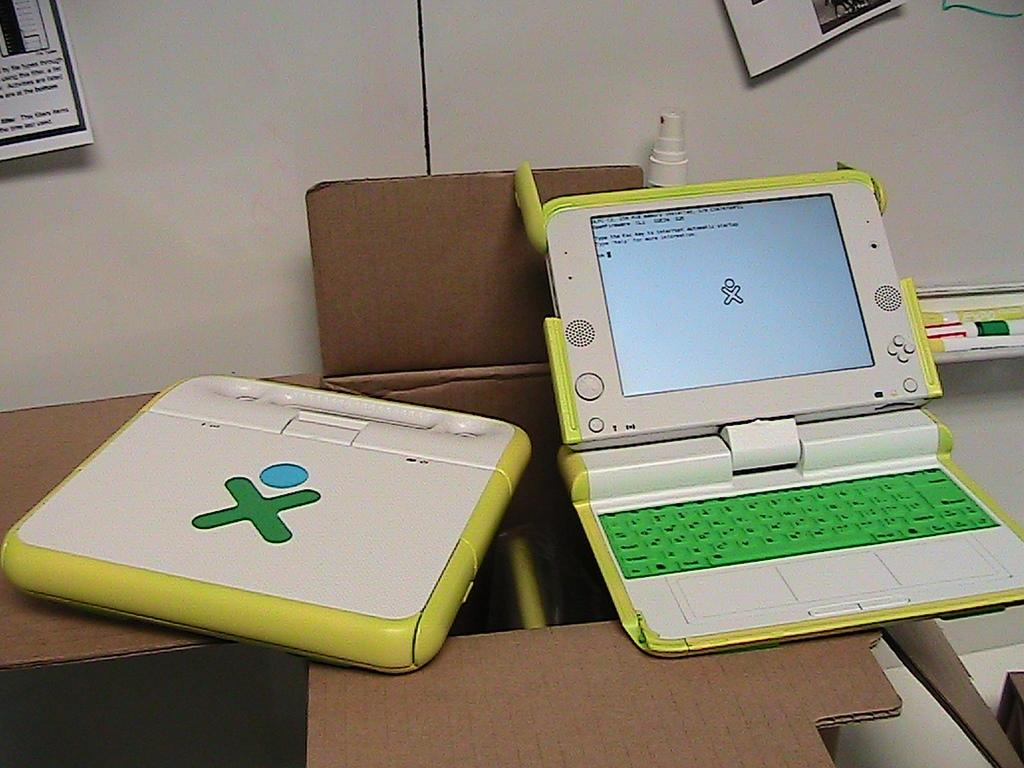What object is in the image that is typically used for storage or transportation? There is a cardboard box in the image. What electronic devices are placed on the cardboard box? There are laptops on the cardboard box. What can be seen in the background of the image? There is a wall with items in the background of the image, and a bottle is visible. How many cows are visible in the image? There are no cows present in the image. What type of jewel is being used to secure the laptops on the cardboard box? There is no jewel present in the image, and the laptops are not secured with any jewelry. 